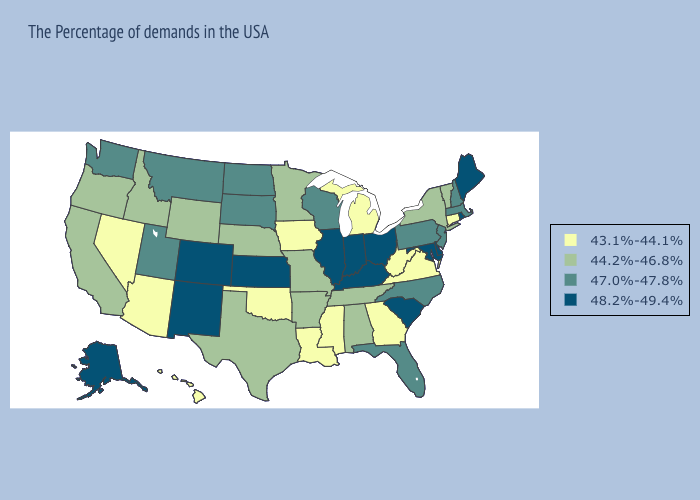Does Wyoming have a lower value than North Dakota?
Be succinct. Yes. Does Iowa have the lowest value in the MidWest?
Keep it brief. Yes. Does Arkansas have the same value as Oklahoma?
Quick response, please. No. Does New Mexico have a lower value than Vermont?
Keep it brief. No. Name the states that have a value in the range 48.2%-49.4%?
Concise answer only. Maine, Rhode Island, Delaware, Maryland, South Carolina, Ohio, Kentucky, Indiana, Illinois, Kansas, Colorado, New Mexico, Alaska. Does the map have missing data?
Concise answer only. No. Name the states that have a value in the range 48.2%-49.4%?
Keep it brief. Maine, Rhode Island, Delaware, Maryland, South Carolina, Ohio, Kentucky, Indiana, Illinois, Kansas, Colorado, New Mexico, Alaska. Among the states that border Colorado , does Kansas have the lowest value?
Answer briefly. No. Name the states that have a value in the range 43.1%-44.1%?
Concise answer only. Connecticut, Virginia, West Virginia, Georgia, Michigan, Mississippi, Louisiana, Iowa, Oklahoma, Arizona, Nevada, Hawaii. What is the value of Indiana?
Answer briefly. 48.2%-49.4%. What is the value of Missouri?
Give a very brief answer. 44.2%-46.8%. Name the states that have a value in the range 43.1%-44.1%?
Concise answer only. Connecticut, Virginia, West Virginia, Georgia, Michigan, Mississippi, Louisiana, Iowa, Oklahoma, Arizona, Nevada, Hawaii. What is the value of Massachusetts?
Short answer required. 47.0%-47.8%. What is the value of Florida?
Be succinct. 47.0%-47.8%. 